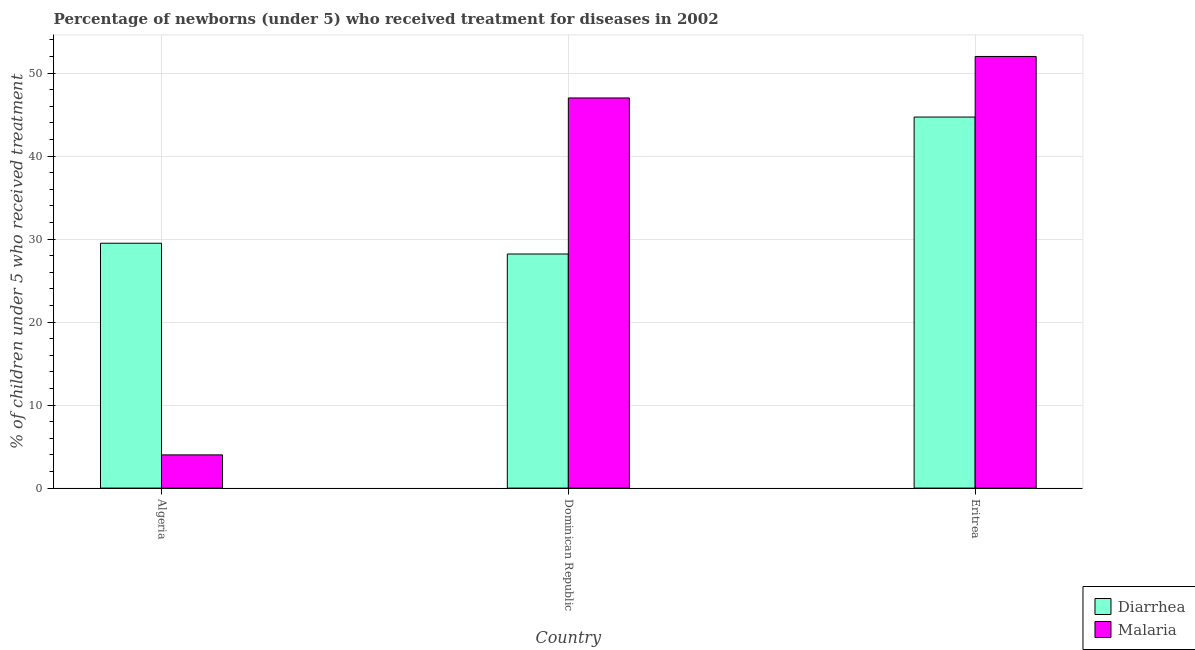Are the number of bars per tick equal to the number of legend labels?
Make the answer very short. Yes. Are the number of bars on each tick of the X-axis equal?
Offer a terse response. Yes. How many bars are there on the 3rd tick from the right?
Make the answer very short. 2. What is the label of the 2nd group of bars from the left?
Give a very brief answer. Dominican Republic. In how many cases, is the number of bars for a given country not equal to the number of legend labels?
Your answer should be very brief. 0. What is the percentage of children who received treatment for diarrhoea in Algeria?
Your response must be concise. 29.5. Across all countries, what is the maximum percentage of children who received treatment for diarrhoea?
Provide a succinct answer. 44.7. Across all countries, what is the minimum percentage of children who received treatment for diarrhoea?
Ensure brevity in your answer.  28.2. In which country was the percentage of children who received treatment for diarrhoea maximum?
Provide a succinct answer. Eritrea. In which country was the percentage of children who received treatment for malaria minimum?
Keep it short and to the point. Algeria. What is the total percentage of children who received treatment for malaria in the graph?
Provide a short and direct response. 103. What is the difference between the percentage of children who received treatment for diarrhoea in Algeria and that in Dominican Republic?
Provide a short and direct response. 1.3. What is the difference between the percentage of children who received treatment for diarrhoea in Algeria and the percentage of children who received treatment for malaria in Dominican Republic?
Give a very brief answer. -17.5. What is the average percentage of children who received treatment for malaria per country?
Your answer should be compact. 34.33. What is the difference between the percentage of children who received treatment for malaria and percentage of children who received treatment for diarrhoea in Algeria?
Give a very brief answer. -25.5. In how many countries, is the percentage of children who received treatment for malaria greater than 18 %?
Make the answer very short. 2. What is the ratio of the percentage of children who received treatment for diarrhoea in Dominican Republic to that in Eritrea?
Keep it short and to the point. 0.63. Is the difference between the percentage of children who received treatment for diarrhoea in Algeria and Eritrea greater than the difference between the percentage of children who received treatment for malaria in Algeria and Eritrea?
Ensure brevity in your answer.  Yes. What is the difference between the highest and the second highest percentage of children who received treatment for diarrhoea?
Offer a terse response. 15.2. What is the difference between the highest and the lowest percentage of children who received treatment for malaria?
Provide a succinct answer. 48. In how many countries, is the percentage of children who received treatment for malaria greater than the average percentage of children who received treatment for malaria taken over all countries?
Make the answer very short. 2. Is the sum of the percentage of children who received treatment for diarrhoea in Dominican Republic and Eritrea greater than the maximum percentage of children who received treatment for malaria across all countries?
Give a very brief answer. Yes. What does the 1st bar from the left in Eritrea represents?
Give a very brief answer. Diarrhea. What does the 1st bar from the right in Dominican Republic represents?
Your response must be concise. Malaria. What is the difference between two consecutive major ticks on the Y-axis?
Make the answer very short. 10. Are the values on the major ticks of Y-axis written in scientific E-notation?
Provide a succinct answer. No. Where does the legend appear in the graph?
Offer a very short reply. Bottom right. What is the title of the graph?
Offer a very short reply. Percentage of newborns (under 5) who received treatment for diseases in 2002. What is the label or title of the Y-axis?
Your answer should be compact. % of children under 5 who received treatment. What is the % of children under 5 who received treatment of Diarrhea in Algeria?
Your response must be concise. 29.5. What is the % of children under 5 who received treatment of Diarrhea in Dominican Republic?
Keep it short and to the point. 28.2. What is the % of children under 5 who received treatment of Malaria in Dominican Republic?
Offer a very short reply. 47. What is the % of children under 5 who received treatment of Diarrhea in Eritrea?
Your response must be concise. 44.7. What is the % of children under 5 who received treatment of Malaria in Eritrea?
Provide a short and direct response. 52. Across all countries, what is the maximum % of children under 5 who received treatment of Diarrhea?
Give a very brief answer. 44.7. Across all countries, what is the maximum % of children under 5 who received treatment in Malaria?
Give a very brief answer. 52. Across all countries, what is the minimum % of children under 5 who received treatment of Diarrhea?
Provide a short and direct response. 28.2. What is the total % of children under 5 who received treatment in Diarrhea in the graph?
Offer a terse response. 102.4. What is the total % of children under 5 who received treatment in Malaria in the graph?
Your answer should be very brief. 103. What is the difference between the % of children under 5 who received treatment in Malaria in Algeria and that in Dominican Republic?
Your response must be concise. -43. What is the difference between the % of children under 5 who received treatment of Diarrhea in Algeria and that in Eritrea?
Your answer should be very brief. -15.2. What is the difference between the % of children under 5 who received treatment of Malaria in Algeria and that in Eritrea?
Provide a succinct answer. -48. What is the difference between the % of children under 5 who received treatment of Diarrhea in Dominican Republic and that in Eritrea?
Provide a short and direct response. -16.5. What is the difference between the % of children under 5 who received treatment in Diarrhea in Algeria and the % of children under 5 who received treatment in Malaria in Dominican Republic?
Keep it short and to the point. -17.5. What is the difference between the % of children under 5 who received treatment in Diarrhea in Algeria and the % of children under 5 who received treatment in Malaria in Eritrea?
Offer a terse response. -22.5. What is the difference between the % of children under 5 who received treatment in Diarrhea in Dominican Republic and the % of children under 5 who received treatment in Malaria in Eritrea?
Your response must be concise. -23.8. What is the average % of children under 5 who received treatment of Diarrhea per country?
Your answer should be compact. 34.13. What is the average % of children under 5 who received treatment of Malaria per country?
Keep it short and to the point. 34.33. What is the difference between the % of children under 5 who received treatment of Diarrhea and % of children under 5 who received treatment of Malaria in Dominican Republic?
Provide a short and direct response. -18.8. What is the ratio of the % of children under 5 who received treatment in Diarrhea in Algeria to that in Dominican Republic?
Your response must be concise. 1.05. What is the ratio of the % of children under 5 who received treatment in Malaria in Algeria to that in Dominican Republic?
Give a very brief answer. 0.09. What is the ratio of the % of children under 5 who received treatment of Diarrhea in Algeria to that in Eritrea?
Your response must be concise. 0.66. What is the ratio of the % of children under 5 who received treatment of Malaria in Algeria to that in Eritrea?
Ensure brevity in your answer.  0.08. What is the ratio of the % of children under 5 who received treatment of Diarrhea in Dominican Republic to that in Eritrea?
Your answer should be very brief. 0.63. What is the ratio of the % of children under 5 who received treatment of Malaria in Dominican Republic to that in Eritrea?
Offer a terse response. 0.9. What is the difference between the highest and the second highest % of children under 5 who received treatment in Diarrhea?
Give a very brief answer. 15.2. What is the difference between the highest and the second highest % of children under 5 who received treatment in Malaria?
Offer a terse response. 5. What is the difference between the highest and the lowest % of children under 5 who received treatment in Diarrhea?
Your response must be concise. 16.5. What is the difference between the highest and the lowest % of children under 5 who received treatment of Malaria?
Your response must be concise. 48. 